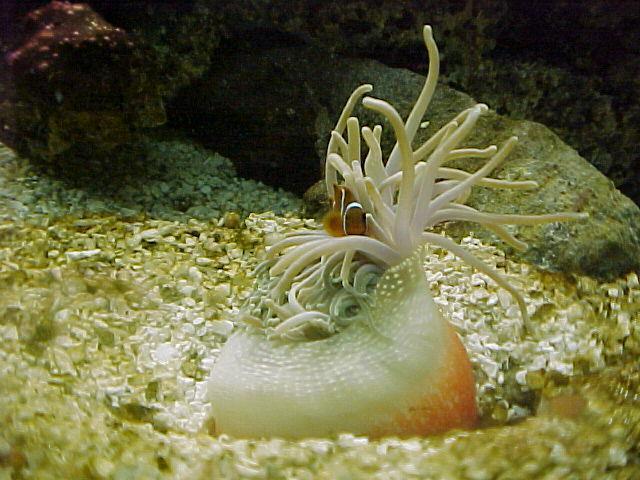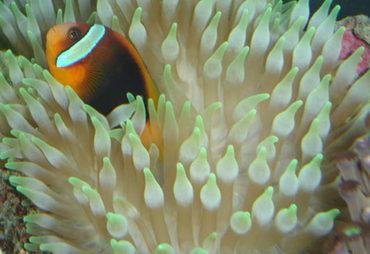The first image is the image on the left, the second image is the image on the right. Given the left and right images, does the statement "At least one image shows a bright yellow anemone with tendrils that have a black dot on the end." hold true? Answer yes or no. No. The first image is the image on the left, the second image is the image on the right. Evaluate the accuracy of this statement regarding the images: "The only living thing in one of the images is an anemone.". Is it true? Answer yes or no. No. 